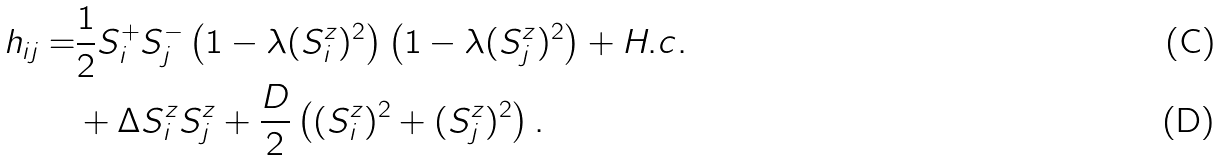<formula> <loc_0><loc_0><loc_500><loc_500>h _ { i j } = & \frac { 1 } { 2 } S _ { i } ^ { + } S _ { j } ^ { - } \left ( 1 - \lambda ( S _ { i } ^ { z } ) ^ { 2 } \right ) \left ( 1 - \lambda ( S _ { j } ^ { z } ) ^ { 2 } \right ) + H . c . \\ & + \Delta S _ { i } ^ { z } S _ { j } ^ { z } + \frac { D } { 2 } \left ( ( S _ { i } ^ { z } ) ^ { 2 } + ( S _ { j } ^ { z } ) ^ { 2 } \right ) .</formula> 